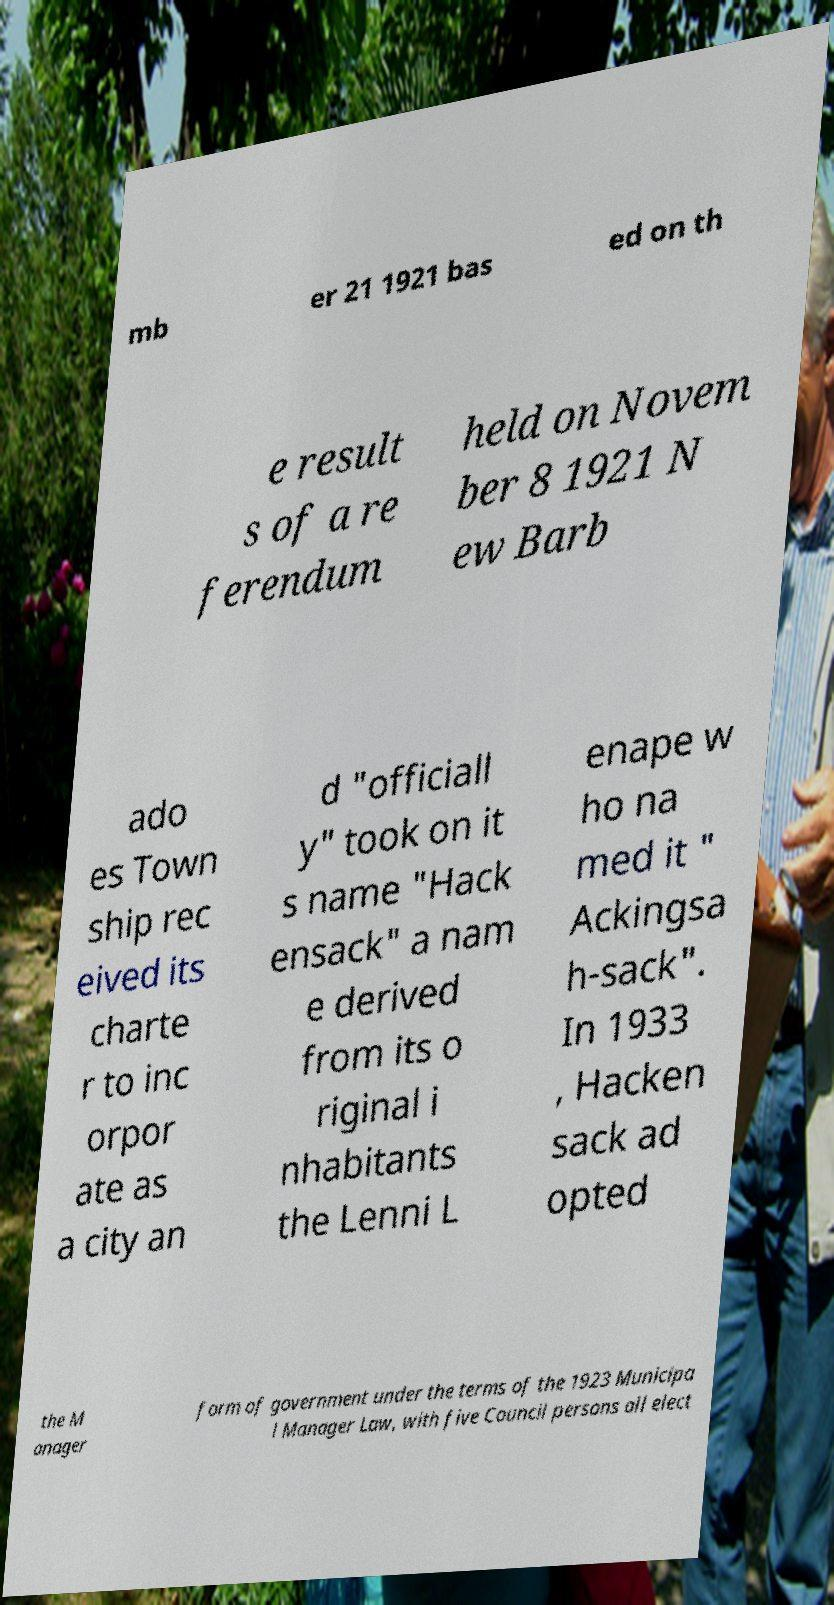Could you extract and type out the text from this image? mb er 21 1921 bas ed on th e result s of a re ferendum held on Novem ber 8 1921 N ew Barb ado es Town ship rec eived its charte r to inc orpor ate as a city an d "officiall y" took on it s name "Hack ensack" a nam e derived from its o riginal i nhabitants the Lenni L enape w ho na med it " Ackingsa h-sack". In 1933 , Hacken sack ad opted the M anager form of government under the terms of the 1923 Municipa l Manager Law, with five Council persons all elect 